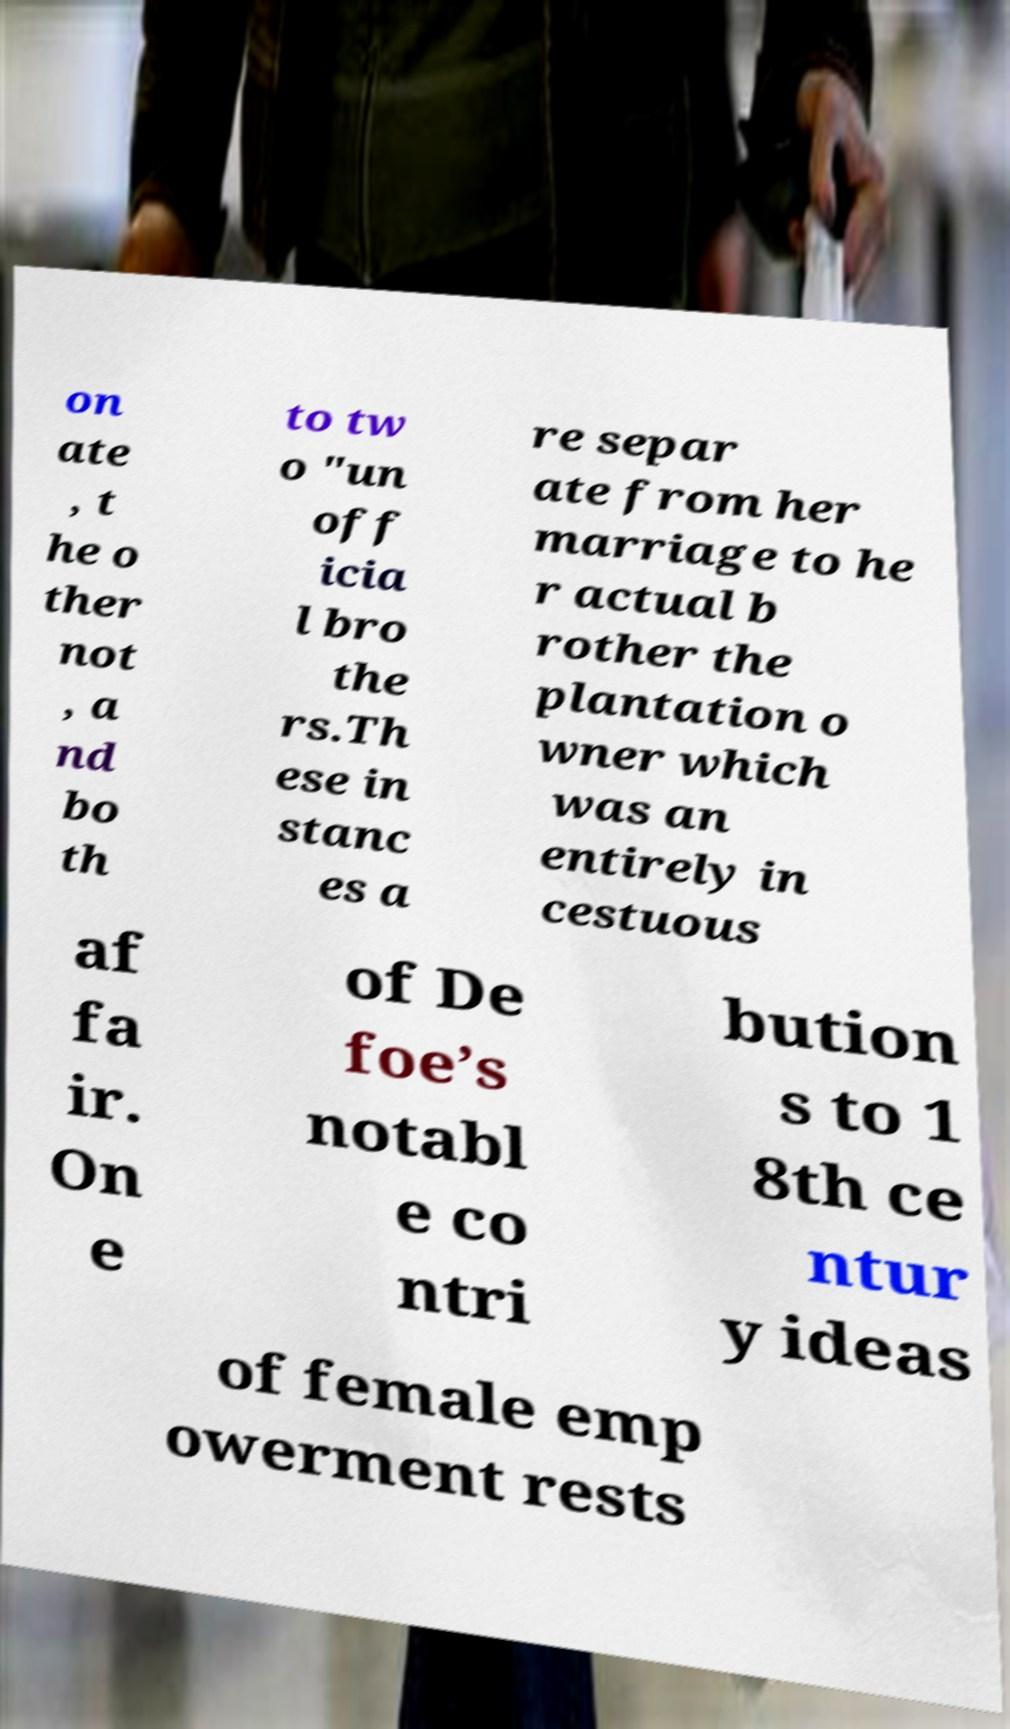Could you extract and type out the text from this image? on ate , t he o ther not , a nd bo th to tw o "un off icia l bro the rs.Th ese in stanc es a re separ ate from her marriage to he r actual b rother the plantation o wner which was an entirely in cestuous af fa ir. On e of De foe’s notabl e co ntri bution s to 1 8th ce ntur y ideas of female emp owerment rests 